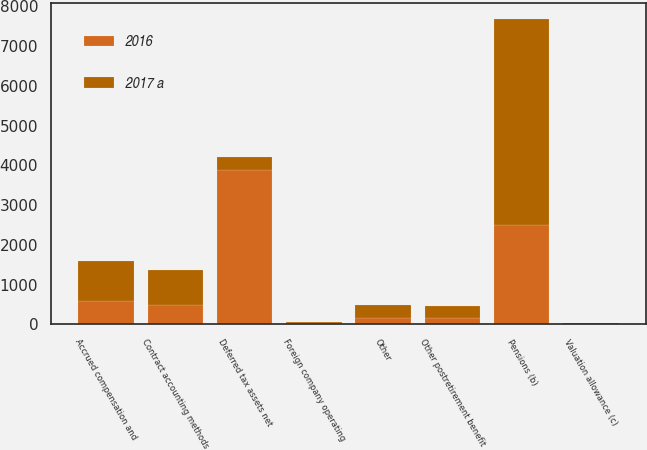Convert chart. <chart><loc_0><loc_0><loc_500><loc_500><stacked_bar_chart><ecel><fcel>Accrued compensation and<fcel>Pensions (b)<fcel>Other postretirement benefit<fcel>Contract accounting methods<fcel>Foreign company operating<fcel>Other<fcel>Valuation allowance (c)<fcel>Deferred tax assets net<nl><fcel>2016<fcel>595<fcel>2495<fcel>153<fcel>487<fcel>27<fcel>154<fcel>20<fcel>3891<nl><fcel>2017 a<fcel>1012<fcel>5197<fcel>302<fcel>878<fcel>30<fcel>327<fcel>15<fcel>327<nl></chart> 